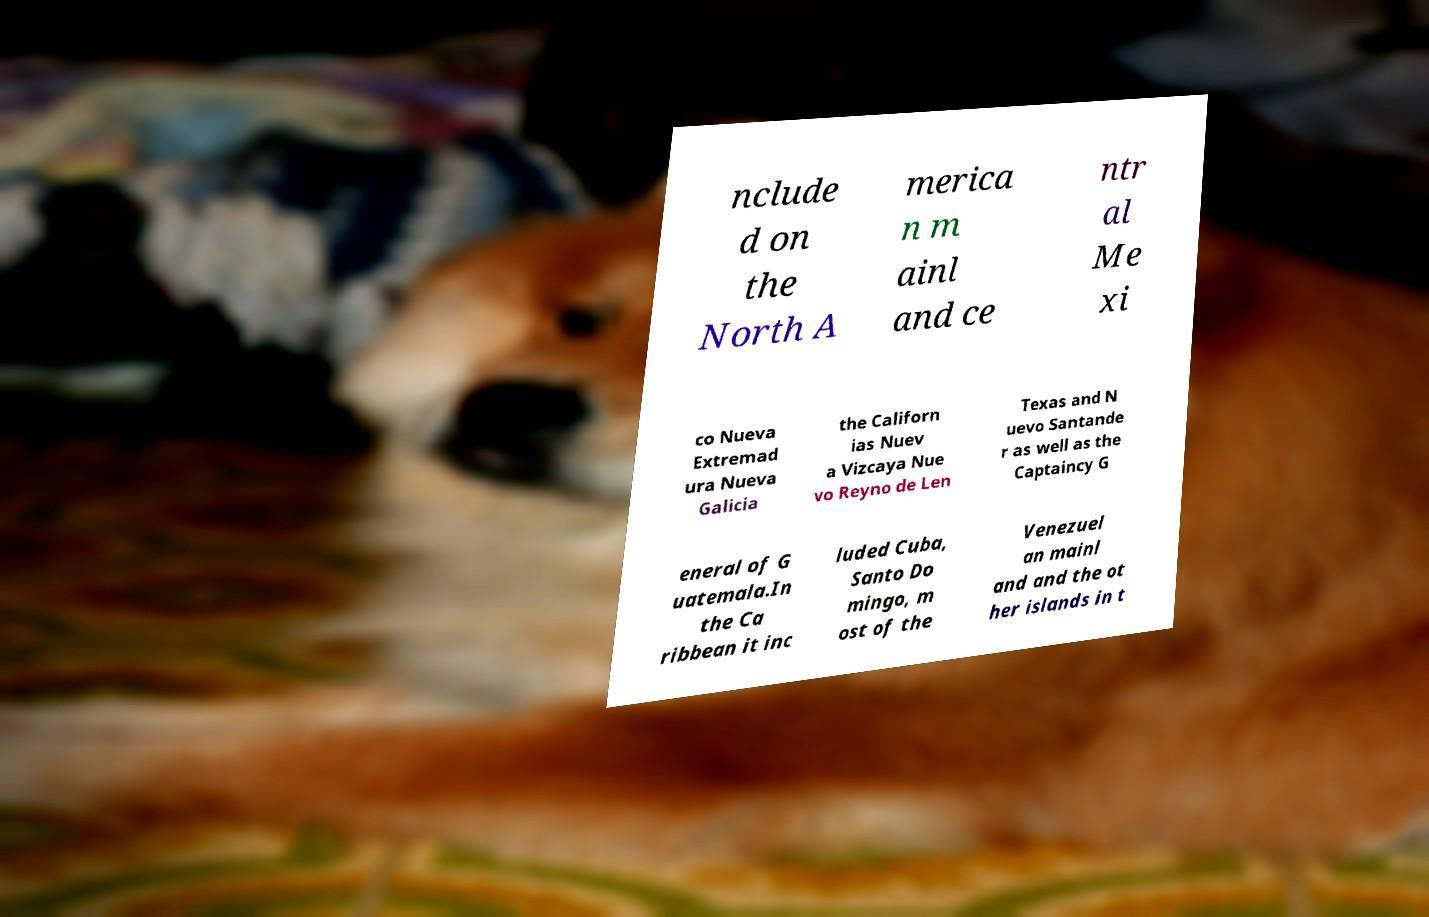Can you accurately transcribe the text from the provided image for me? nclude d on the North A merica n m ainl and ce ntr al Me xi co Nueva Extremad ura Nueva Galicia the Californ ias Nuev a Vizcaya Nue vo Reyno de Len Texas and N uevo Santande r as well as the Captaincy G eneral of G uatemala.In the Ca ribbean it inc luded Cuba, Santo Do mingo, m ost of the Venezuel an mainl and and the ot her islands in t 